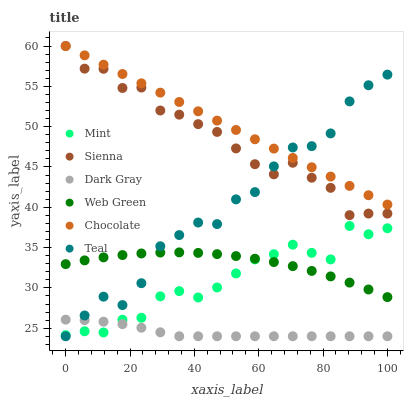Does Dark Gray have the minimum area under the curve?
Answer yes or no. Yes. Does Chocolate have the maximum area under the curve?
Answer yes or no. Yes. Does Web Green have the minimum area under the curve?
Answer yes or no. No. Does Web Green have the maximum area under the curve?
Answer yes or no. No. Is Chocolate the smoothest?
Answer yes or no. Yes. Is Teal the roughest?
Answer yes or no. Yes. Is Web Green the smoothest?
Answer yes or no. No. Is Web Green the roughest?
Answer yes or no. No. Does Dark Gray have the lowest value?
Answer yes or no. Yes. Does Web Green have the lowest value?
Answer yes or no. No. Does Sienna have the highest value?
Answer yes or no. Yes. Does Web Green have the highest value?
Answer yes or no. No. Is Mint less than Chocolate?
Answer yes or no. Yes. Is Web Green greater than Dark Gray?
Answer yes or no. Yes. Does Mint intersect Teal?
Answer yes or no. Yes. Is Mint less than Teal?
Answer yes or no. No. Is Mint greater than Teal?
Answer yes or no. No. Does Mint intersect Chocolate?
Answer yes or no. No. 